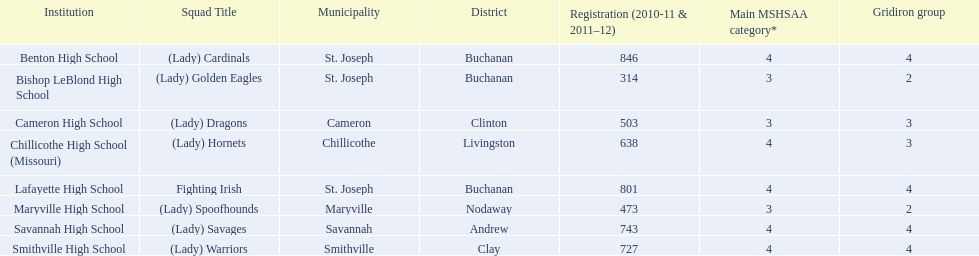Benton high school and bishop leblond high school are both located in what town? St. Joseph. 